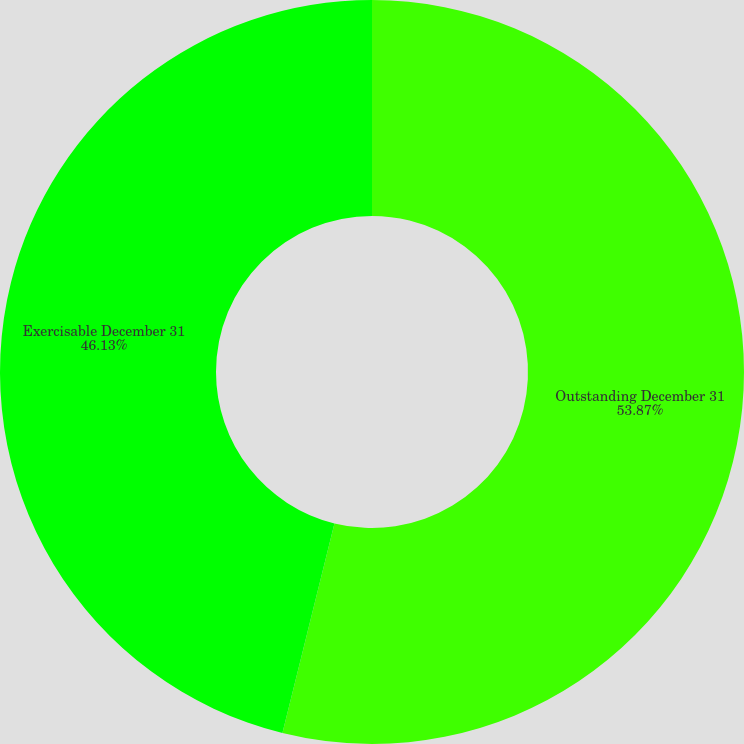<chart> <loc_0><loc_0><loc_500><loc_500><pie_chart><fcel>Outstanding December 31<fcel>Exercisable December 31<nl><fcel>53.87%<fcel>46.13%<nl></chart> 